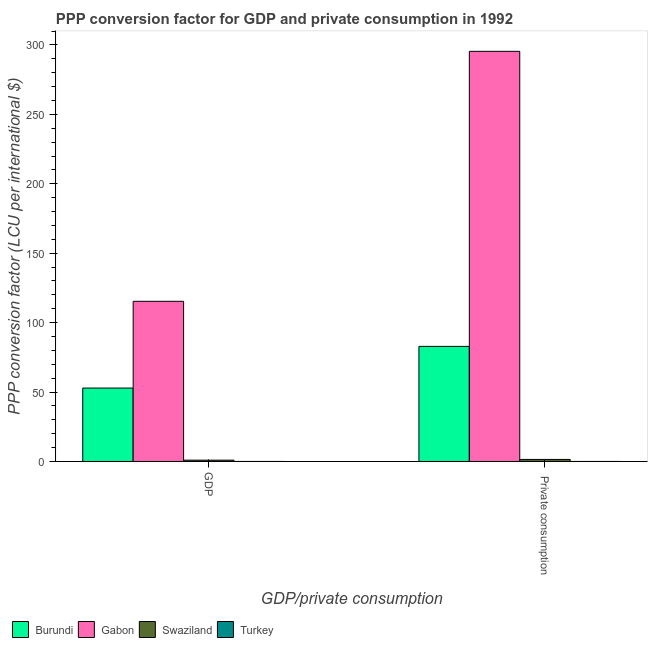How many different coloured bars are there?
Provide a short and direct response. 4. How many groups of bars are there?
Your response must be concise. 2. Are the number of bars per tick equal to the number of legend labels?
Ensure brevity in your answer.  Yes. How many bars are there on the 2nd tick from the left?
Offer a very short reply. 4. How many bars are there on the 2nd tick from the right?
Your answer should be compact. 4. What is the label of the 1st group of bars from the left?
Ensure brevity in your answer.  GDP. What is the ppp conversion factor for gdp in Swaziland?
Keep it short and to the point. 0.94. Across all countries, what is the maximum ppp conversion factor for gdp?
Make the answer very short. 115.35. Across all countries, what is the minimum ppp conversion factor for private consumption?
Ensure brevity in your answer.  0. In which country was the ppp conversion factor for private consumption maximum?
Ensure brevity in your answer.  Gabon. In which country was the ppp conversion factor for private consumption minimum?
Your response must be concise. Turkey. What is the total ppp conversion factor for gdp in the graph?
Provide a short and direct response. 169.17. What is the difference between the ppp conversion factor for gdp in Gabon and that in Burundi?
Offer a very short reply. 62.47. What is the difference between the ppp conversion factor for gdp in Swaziland and the ppp conversion factor for private consumption in Gabon?
Your answer should be compact. -294.45. What is the average ppp conversion factor for private consumption per country?
Make the answer very short. 94.94. What is the difference between the ppp conversion factor for gdp and ppp conversion factor for private consumption in Burundi?
Your answer should be very brief. -30.01. What is the ratio of the ppp conversion factor for gdp in Gabon to that in Swaziland?
Your answer should be very brief. 123.08. Is the ppp conversion factor for gdp in Gabon less than that in Turkey?
Your answer should be very brief. No. In how many countries, is the ppp conversion factor for gdp greater than the average ppp conversion factor for gdp taken over all countries?
Your response must be concise. 2. What does the 2nd bar from the left in  Private consumption represents?
Give a very brief answer. Gabon. What does the 4th bar from the right in GDP represents?
Offer a terse response. Burundi. What is the difference between two consecutive major ticks on the Y-axis?
Offer a very short reply. 50. Are the values on the major ticks of Y-axis written in scientific E-notation?
Your answer should be compact. No. Does the graph contain any zero values?
Ensure brevity in your answer.  No. Does the graph contain grids?
Provide a short and direct response. No. Where does the legend appear in the graph?
Provide a short and direct response. Bottom left. What is the title of the graph?
Provide a short and direct response. PPP conversion factor for GDP and private consumption in 1992. What is the label or title of the X-axis?
Give a very brief answer. GDP/private consumption. What is the label or title of the Y-axis?
Offer a terse response. PPP conversion factor (LCU per international $). What is the PPP conversion factor (LCU per international $) in Burundi in GDP?
Provide a succinct answer. 52.88. What is the PPP conversion factor (LCU per international $) in Gabon in GDP?
Ensure brevity in your answer.  115.35. What is the PPP conversion factor (LCU per international $) in Swaziland in GDP?
Offer a very short reply. 0.94. What is the PPP conversion factor (LCU per international $) of Turkey in GDP?
Give a very brief answer. 0. What is the PPP conversion factor (LCU per international $) in Burundi in  Private consumption?
Offer a very short reply. 82.88. What is the PPP conversion factor (LCU per international $) in Gabon in  Private consumption?
Offer a terse response. 295.39. What is the PPP conversion factor (LCU per international $) in Swaziland in  Private consumption?
Your answer should be compact. 1.47. What is the PPP conversion factor (LCU per international $) of Turkey in  Private consumption?
Your response must be concise. 0. Across all GDP/private consumption, what is the maximum PPP conversion factor (LCU per international $) of Burundi?
Offer a terse response. 82.88. Across all GDP/private consumption, what is the maximum PPP conversion factor (LCU per international $) of Gabon?
Give a very brief answer. 295.39. Across all GDP/private consumption, what is the maximum PPP conversion factor (LCU per international $) of Swaziland?
Keep it short and to the point. 1.47. Across all GDP/private consumption, what is the maximum PPP conversion factor (LCU per international $) in Turkey?
Offer a very short reply. 0. Across all GDP/private consumption, what is the minimum PPP conversion factor (LCU per international $) of Burundi?
Give a very brief answer. 52.88. Across all GDP/private consumption, what is the minimum PPP conversion factor (LCU per international $) of Gabon?
Your answer should be compact. 115.35. Across all GDP/private consumption, what is the minimum PPP conversion factor (LCU per international $) of Swaziland?
Ensure brevity in your answer.  0.94. Across all GDP/private consumption, what is the minimum PPP conversion factor (LCU per international $) in Turkey?
Provide a short and direct response. 0. What is the total PPP conversion factor (LCU per international $) in Burundi in the graph?
Offer a terse response. 135.76. What is the total PPP conversion factor (LCU per international $) in Gabon in the graph?
Your answer should be compact. 410.74. What is the total PPP conversion factor (LCU per international $) of Swaziland in the graph?
Give a very brief answer. 2.4. What is the total PPP conversion factor (LCU per international $) in Turkey in the graph?
Your answer should be very brief. 0.01. What is the difference between the PPP conversion factor (LCU per international $) of Burundi in GDP and that in  Private consumption?
Your answer should be very brief. -30.01. What is the difference between the PPP conversion factor (LCU per international $) in Gabon in GDP and that in  Private consumption?
Your answer should be compact. -180.04. What is the difference between the PPP conversion factor (LCU per international $) in Swaziland in GDP and that in  Private consumption?
Provide a short and direct response. -0.53. What is the difference between the PPP conversion factor (LCU per international $) of Turkey in GDP and that in  Private consumption?
Your response must be concise. -0. What is the difference between the PPP conversion factor (LCU per international $) in Burundi in GDP and the PPP conversion factor (LCU per international $) in Gabon in  Private consumption?
Offer a very short reply. -242.51. What is the difference between the PPP conversion factor (LCU per international $) of Burundi in GDP and the PPP conversion factor (LCU per international $) of Swaziland in  Private consumption?
Offer a very short reply. 51.41. What is the difference between the PPP conversion factor (LCU per international $) in Burundi in GDP and the PPP conversion factor (LCU per international $) in Turkey in  Private consumption?
Provide a succinct answer. 52.87. What is the difference between the PPP conversion factor (LCU per international $) of Gabon in GDP and the PPP conversion factor (LCU per international $) of Swaziland in  Private consumption?
Provide a succinct answer. 113.88. What is the difference between the PPP conversion factor (LCU per international $) of Gabon in GDP and the PPP conversion factor (LCU per international $) of Turkey in  Private consumption?
Ensure brevity in your answer.  115.35. What is the difference between the PPP conversion factor (LCU per international $) in Swaziland in GDP and the PPP conversion factor (LCU per international $) in Turkey in  Private consumption?
Your answer should be compact. 0.93. What is the average PPP conversion factor (LCU per international $) of Burundi per GDP/private consumption?
Your answer should be very brief. 67.88. What is the average PPP conversion factor (LCU per international $) of Gabon per GDP/private consumption?
Keep it short and to the point. 205.37. What is the average PPP conversion factor (LCU per international $) in Swaziland per GDP/private consumption?
Offer a very short reply. 1.2. What is the average PPP conversion factor (LCU per international $) of Turkey per GDP/private consumption?
Provide a succinct answer. 0. What is the difference between the PPP conversion factor (LCU per international $) of Burundi and PPP conversion factor (LCU per international $) of Gabon in GDP?
Offer a very short reply. -62.47. What is the difference between the PPP conversion factor (LCU per international $) in Burundi and PPP conversion factor (LCU per international $) in Swaziland in GDP?
Offer a terse response. 51.94. What is the difference between the PPP conversion factor (LCU per international $) in Burundi and PPP conversion factor (LCU per international $) in Turkey in GDP?
Your response must be concise. 52.87. What is the difference between the PPP conversion factor (LCU per international $) of Gabon and PPP conversion factor (LCU per international $) of Swaziland in GDP?
Provide a short and direct response. 114.41. What is the difference between the PPP conversion factor (LCU per international $) in Gabon and PPP conversion factor (LCU per international $) in Turkey in GDP?
Provide a short and direct response. 115.35. What is the difference between the PPP conversion factor (LCU per international $) of Swaziland and PPP conversion factor (LCU per international $) of Turkey in GDP?
Your answer should be compact. 0.93. What is the difference between the PPP conversion factor (LCU per international $) in Burundi and PPP conversion factor (LCU per international $) in Gabon in  Private consumption?
Your answer should be very brief. -212.51. What is the difference between the PPP conversion factor (LCU per international $) of Burundi and PPP conversion factor (LCU per international $) of Swaziland in  Private consumption?
Make the answer very short. 81.42. What is the difference between the PPP conversion factor (LCU per international $) of Burundi and PPP conversion factor (LCU per international $) of Turkey in  Private consumption?
Offer a terse response. 82.88. What is the difference between the PPP conversion factor (LCU per international $) in Gabon and PPP conversion factor (LCU per international $) in Swaziland in  Private consumption?
Give a very brief answer. 293.92. What is the difference between the PPP conversion factor (LCU per international $) in Gabon and PPP conversion factor (LCU per international $) in Turkey in  Private consumption?
Keep it short and to the point. 295.39. What is the difference between the PPP conversion factor (LCU per international $) in Swaziland and PPP conversion factor (LCU per international $) in Turkey in  Private consumption?
Provide a succinct answer. 1.46. What is the ratio of the PPP conversion factor (LCU per international $) of Burundi in GDP to that in  Private consumption?
Your answer should be very brief. 0.64. What is the ratio of the PPP conversion factor (LCU per international $) of Gabon in GDP to that in  Private consumption?
Make the answer very short. 0.39. What is the ratio of the PPP conversion factor (LCU per international $) of Swaziland in GDP to that in  Private consumption?
Offer a very short reply. 0.64. What is the ratio of the PPP conversion factor (LCU per international $) of Turkey in GDP to that in  Private consumption?
Your answer should be compact. 0.94. What is the difference between the highest and the second highest PPP conversion factor (LCU per international $) of Burundi?
Offer a terse response. 30.01. What is the difference between the highest and the second highest PPP conversion factor (LCU per international $) of Gabon?
Provide a short and direct response. 180.04. What is the difference between the highest and the second highest PPP conversion factor (LCU per international $) in Swaziland?
Keep it short and to the point. 0.53. What is the difference between the highest and the second highest PPP conversion factor (LCU per international $) of Turkey?
Make the answer very short. 0. What is the difference between the highest and the lowest PPP conversion factor (LCU per international $) in Burundi?
Keep it short and to the point. 30.01. What is the difference between the highest and the lowest PPP conversion factor (LCU per international $) in Gabon?
Keep it short and to the point. 180.04. What is the difference between the highest and the lowest PPP conversion factor (LCU per international $) of Swaziland?
Provide a succinct answer. 0.53. 